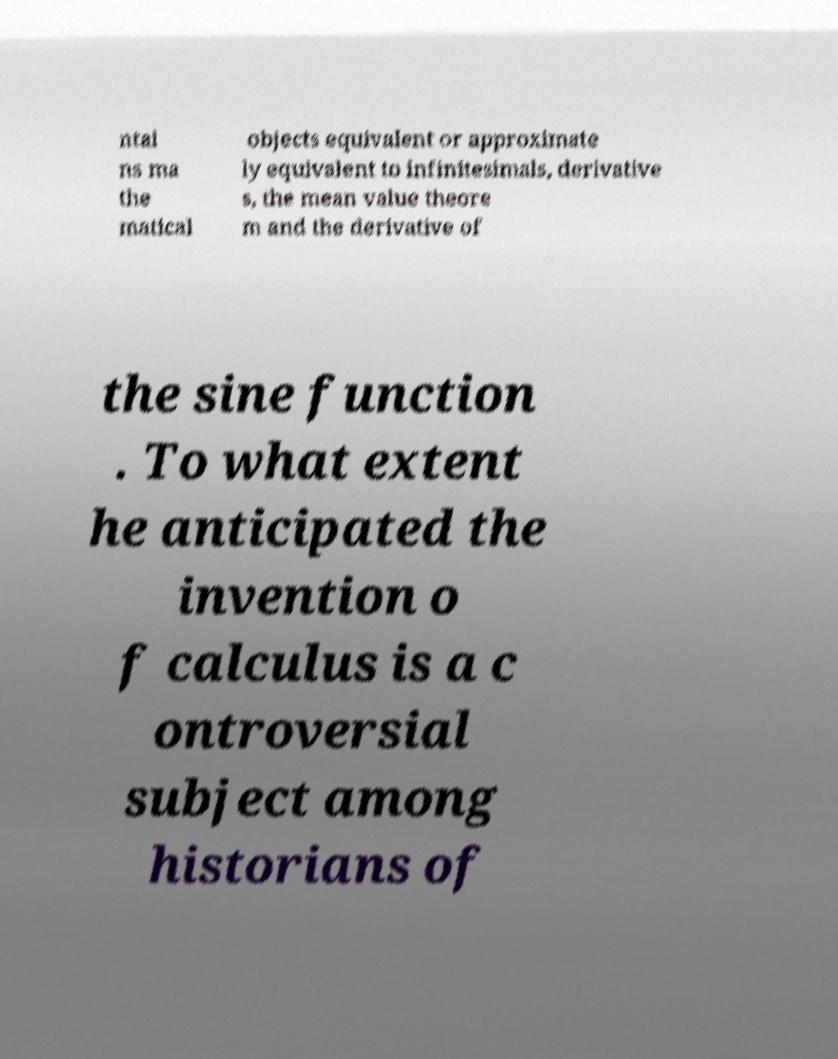Please identify and transcribe the text found in this image. ntai ns ma the matical objects equivalent or approximate ly equivalent to infinitesimals, derivative s, the mean value theore m and the derivative of the sine function . To what extent he anticipated the invention o f calculus is a c ontroversial subject among historians of 